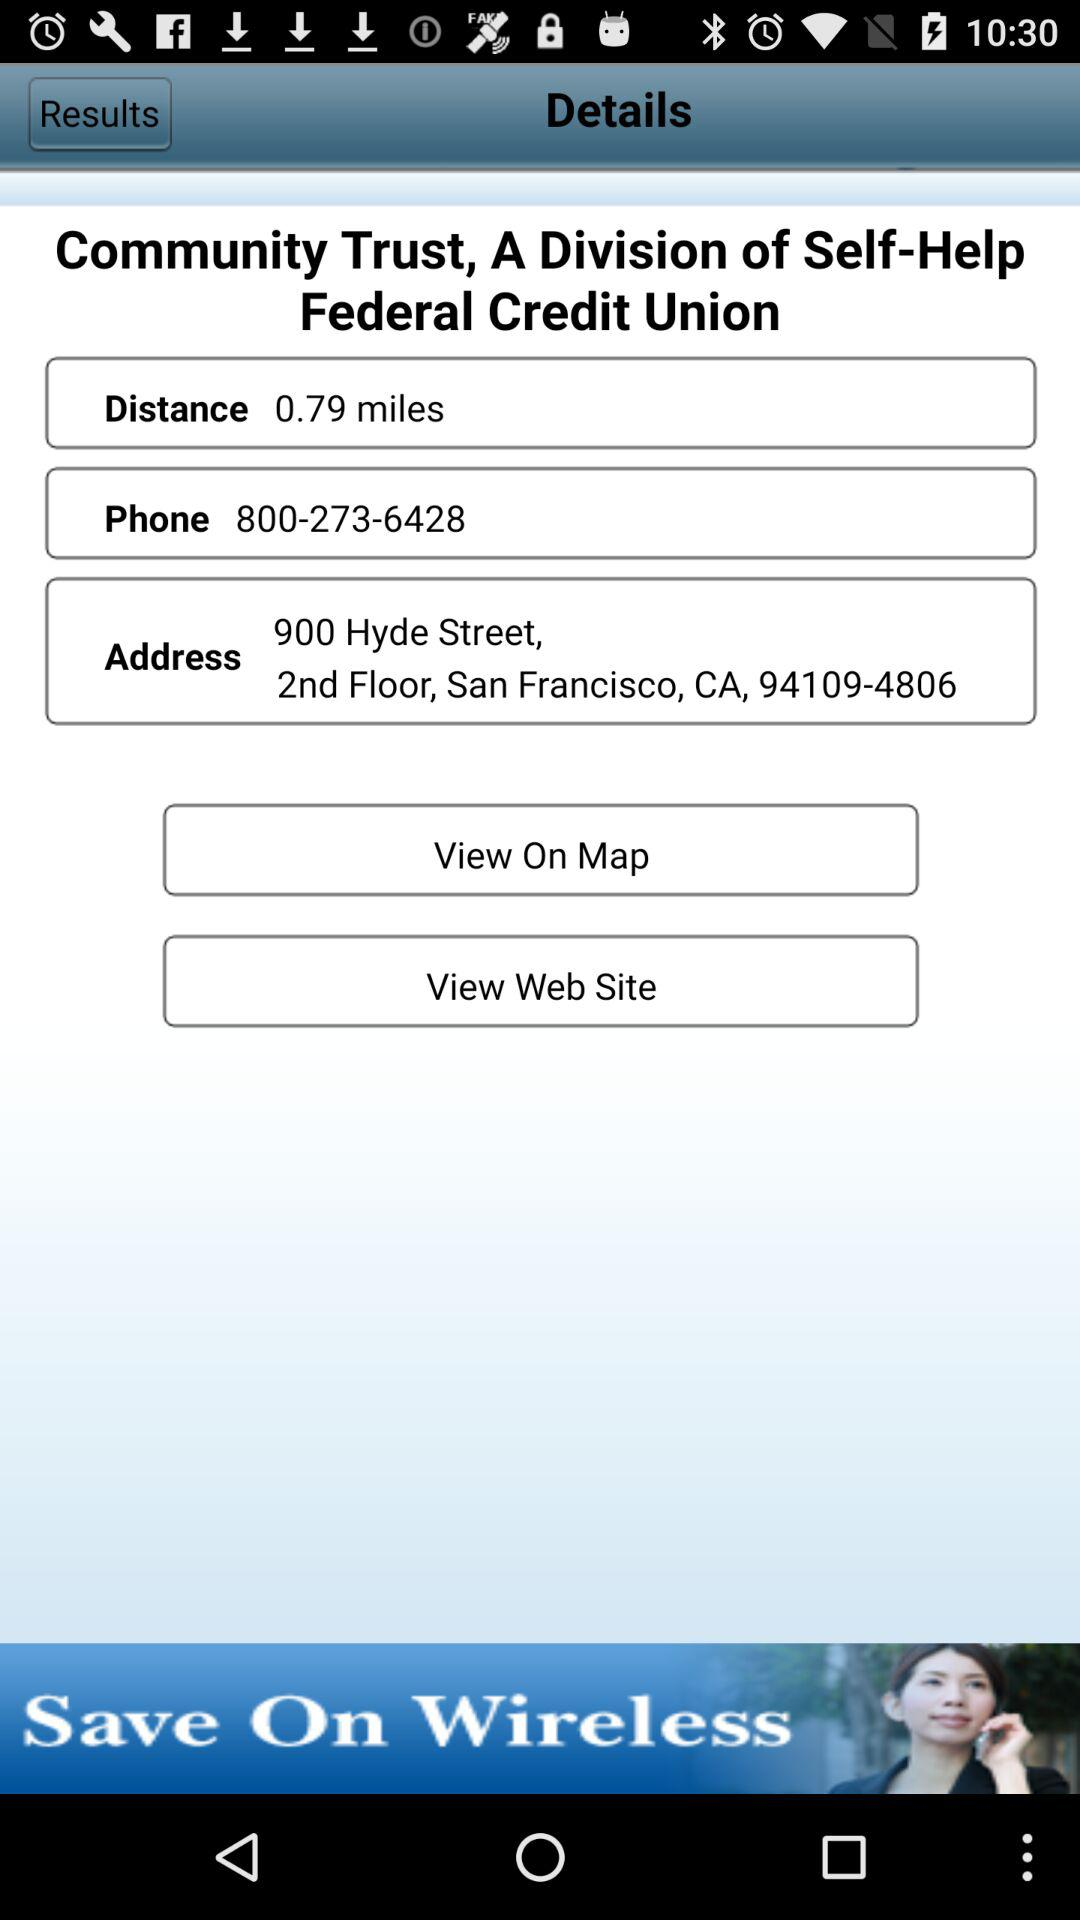What is the website URL?
When the provided information is insufficient, respond with <no answer>. <no answer> 